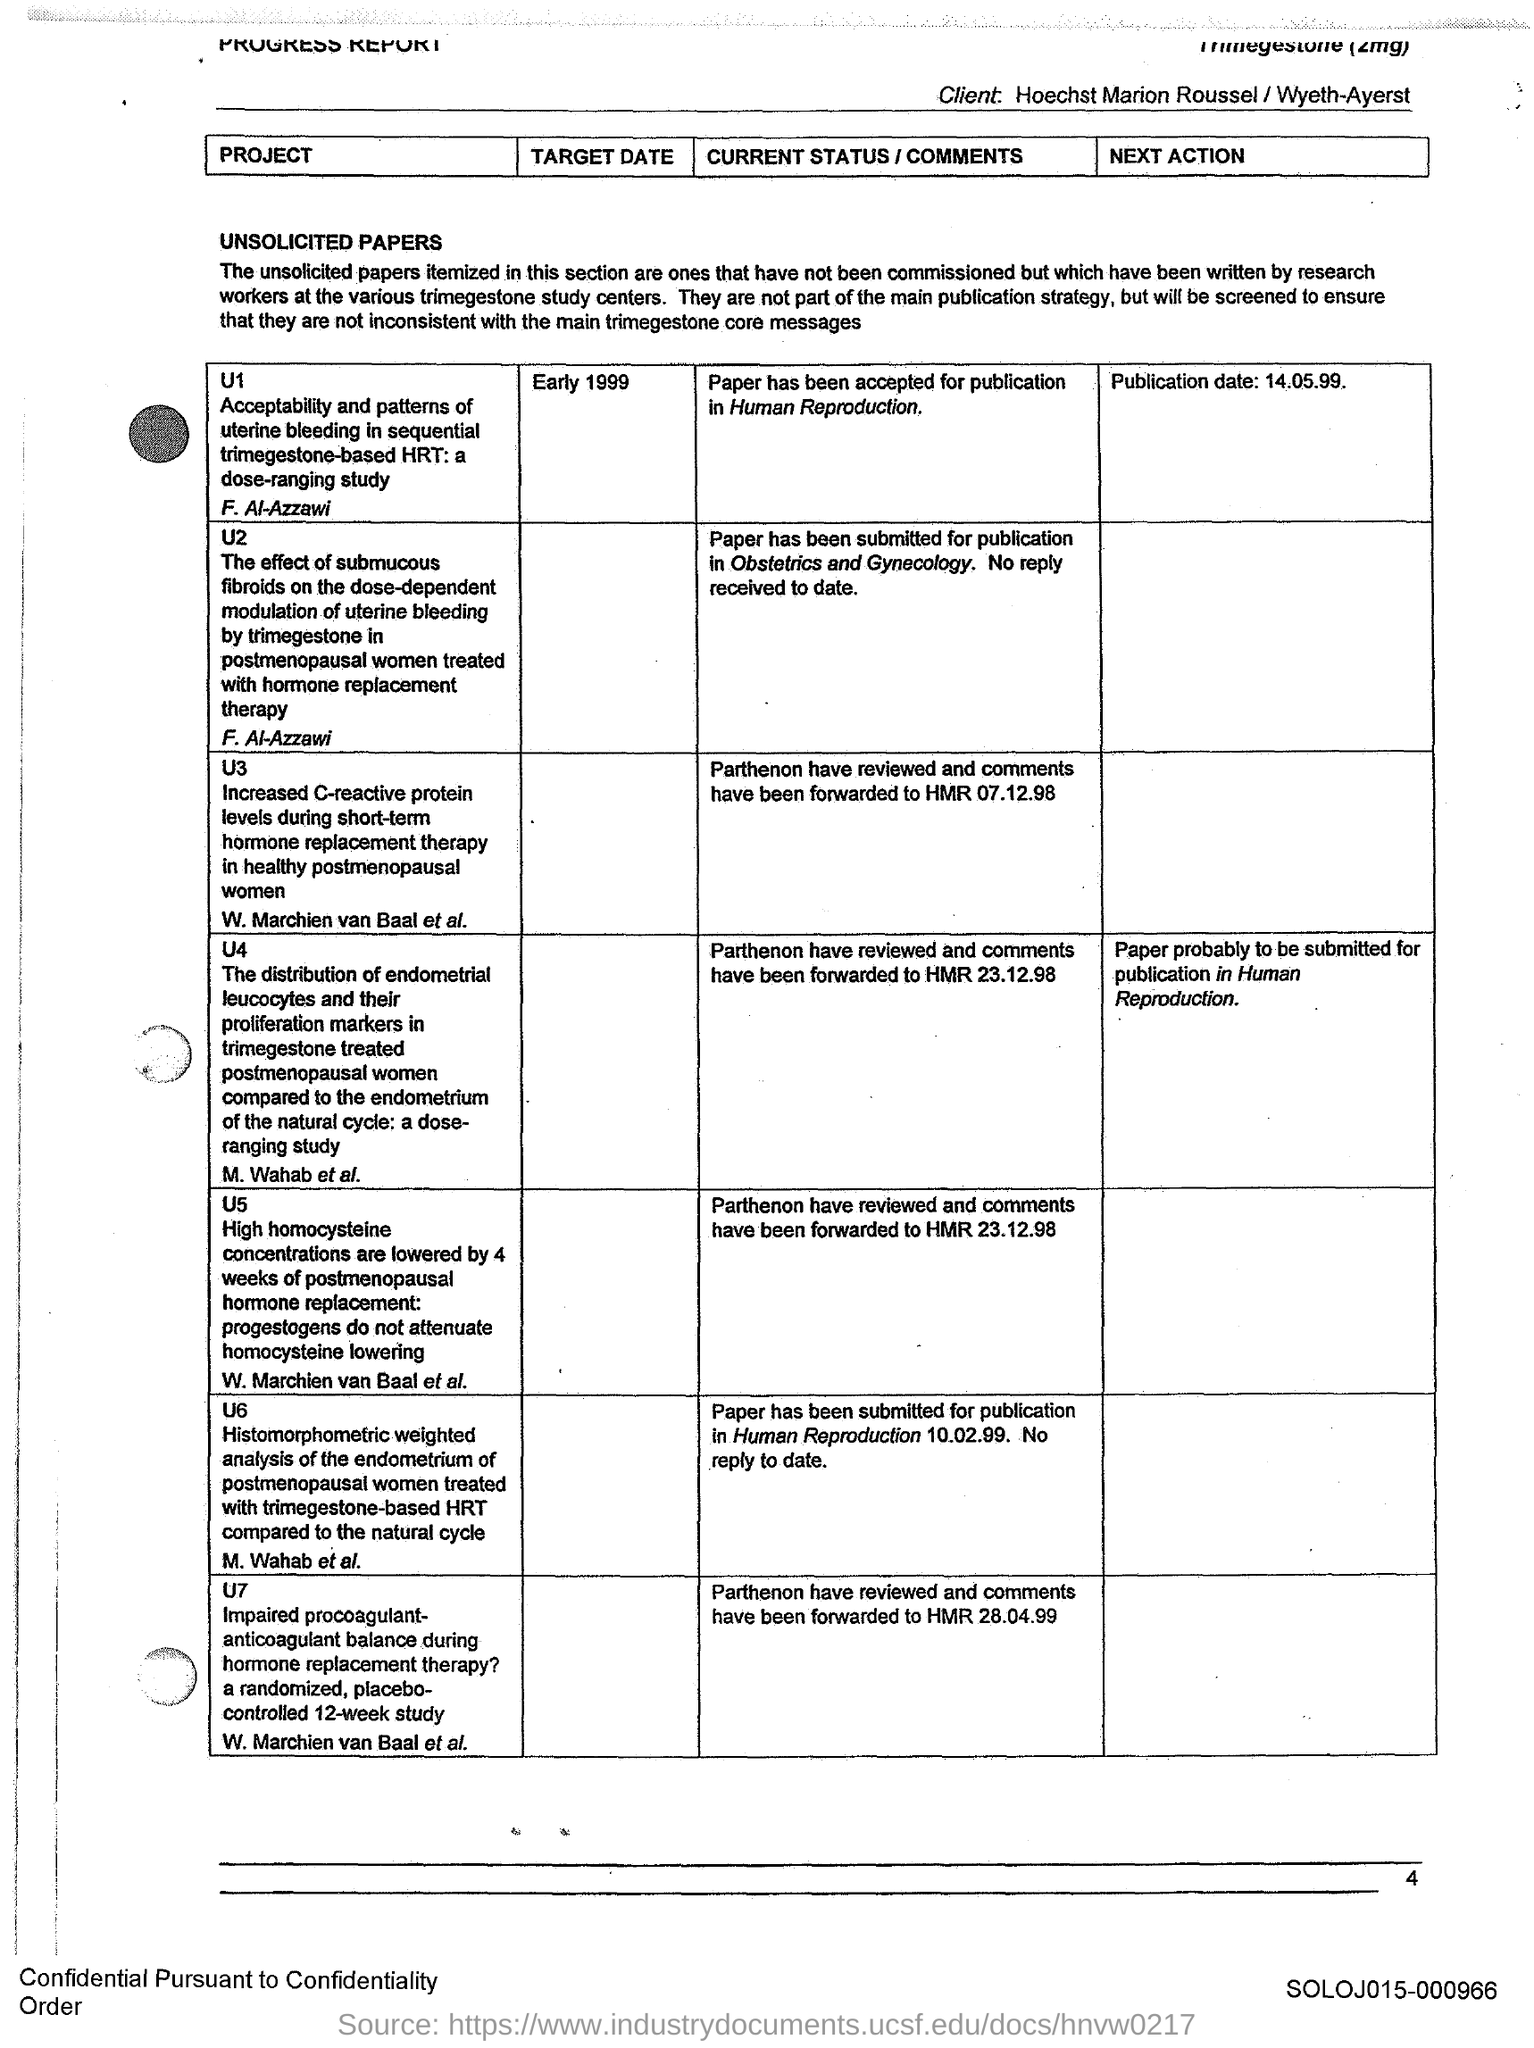Give some essential details in this illustration. The publication date of project U1 is May 14, 1999. The target date for the project U1 is early 1999. The page number is 4. 